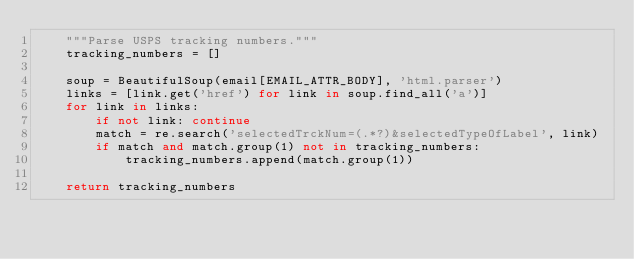Convert code to text. <code><loc_0><loc_0><loc_500><loc_500><_Python_>    """Parse USPS tracking numbers."""
    tracking_numbers = []

    soup = BeautifulSoup(email[EMAIL_ATTR_BODY], 'html.parser')
    links = [link.get('href') for link in soup.find_all('a')]
    for link in links:
        if not link: continue
        match = re.search('selectedTrckNum=(.*?)&selectedTypeOfLabel', link)
        if match and match.group(1) not in tracking_numbers:
            tracking_numbers.append(match.group(1))
                
    return tracking_numbers
    
</code> 